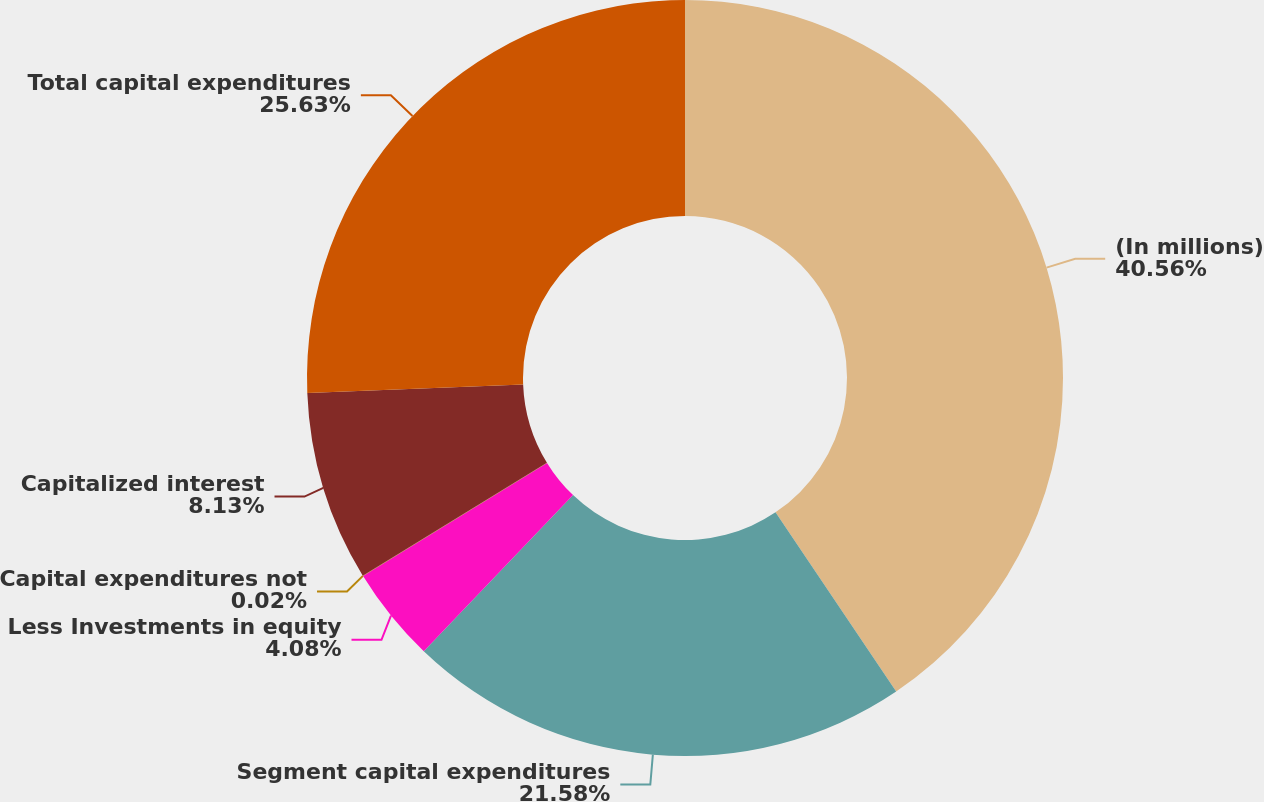<chart> <loc_0><loc_0><loc_500><loc_500><pie_chart><fcel>(In millions)<fcel>Segment capital expenditures<fcel>Less Investments in equity<fcel>Capital expenditures not<fcel>Capitalized interest<fcel>Total capital expenditures<nl><fcel>40.57%<fcel>21.58%<fcel>4.08%<fcel>0.02%<fcel>8.13%<fcel>25.63%<nl></chart> 